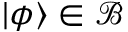<formula> <loc_0><loc_0><loc_500><loc_500>| \phi \rangle \in { \mathcal { B } }</formula> 